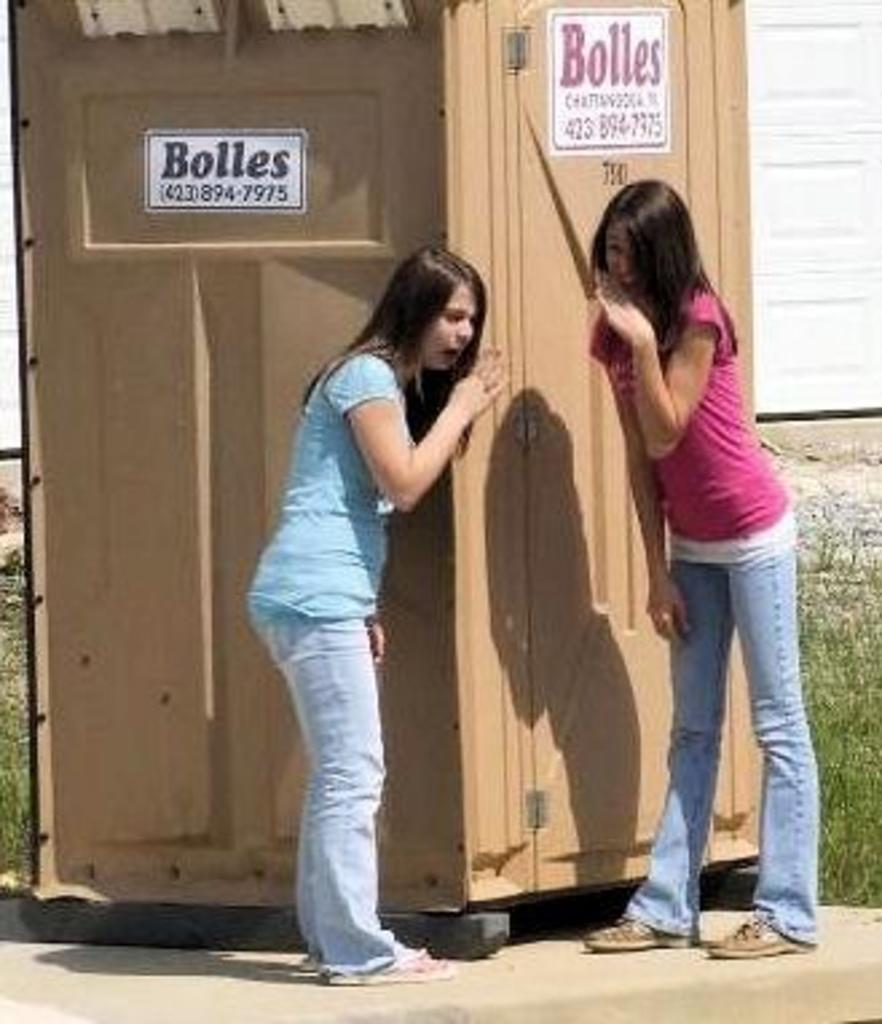In one or two sentences, can you explain what this image depicts? Two girls are standing, this is a booth, these are plants. 